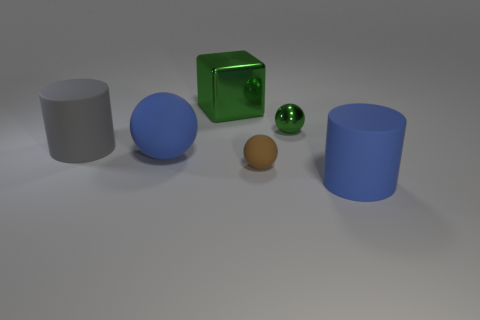There is a gray thing that is the same material as the blue sphere; what is its shape?
Your answer should be compact. Cylinder. Are there any other things that have the same shape as the small rubber thing?
Offer a terse response. Yes. Do the small brown ball behind the blue cylinder and the large gray thing have the same material?
Provide a succinct answer. Yes. There is a blue object that is left of the metal cube; what is its material?
Make the answer very short. Rubber. There is a matte cylinder to the right of the big gray cylinder to the left of the big shiny block; how big is it?
Offer a very short reply. Large. How many matte balls are the same size as the brown matte object?
Provide a short and direct response. 0. There is a cylinder left of the green metallic block; is its color the same as the large thing that is on the right side of the tiny green ball?
Make the answer very short. No. Are there any green metal cubes in front of the big metal thing?
Keep it short and to the point. No. There is a large rubber thing that is both in front of the gray cylinder and left of the small shiny sphere; what color is it?
Give a very brief answer. Blue. Are there any other blocks that have the same color as the shiny cube?
Ensure brevity in your answer.  No. 